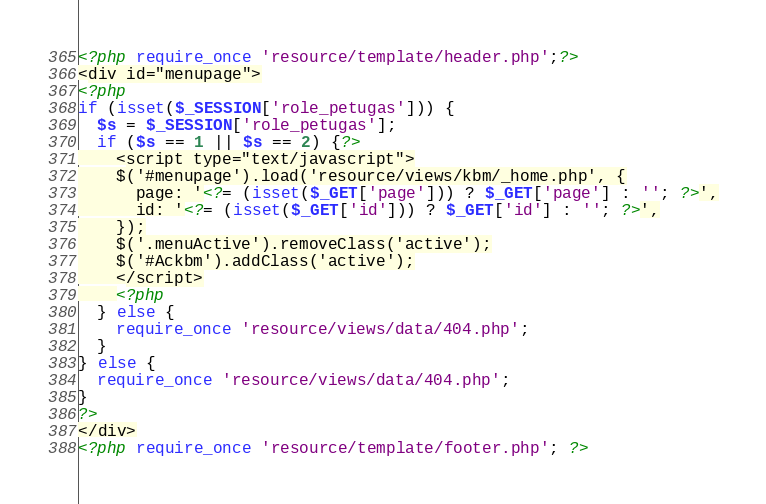Convert code to text. <code><loc_0><loc_0><loc_500><loc_500><_PHP_><?php require_once 'resource/template/header.php';?>
<div id="menupage">
<?php
if (isset($_SESSION['role_petugas'])) {
  $s = $_SESSION['role_petugas'];
  if ($s == 1 || $s == 2) {?>
    <script type="text/javascript">
    $('#menupage').load('resource/views/kbm/_home.php', {
      page: '<?= (isset($_GET['page'])) ? $_GET['page'] : ''; ?>',
      id: '<?= (isset($_GET['id'])) ? $_GET['id'] : ''; ?>',
    });
    $('.menuActive').removeClass('active');
    $('#Ackbm').addClass('active');
    </script>
    <?php
  } else {
    require_once 'resource/views/data/404.php';
  }
} else {
  require_once 'resource/views/data/404.php';
}
?>
</div>
<?php require_once 'resource/template/footer.php'; ?>
</code> 